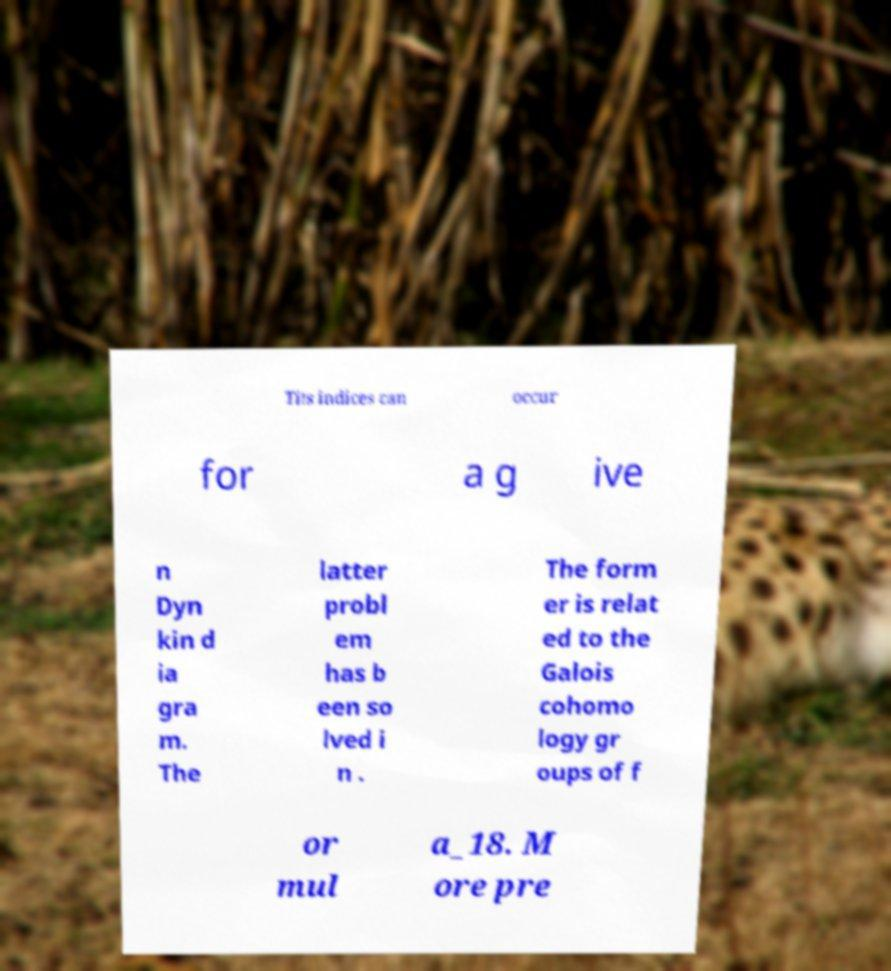What messages or text are displayed in this image? I need them in a readable, typed format. Tits indices can occur for a g ive n Dyn kin d ia gra m. The latter probl em has b een so lved i n . The form er is relat ed to the Galois cohomo logy gr oups of f or mul a_18. M ore pre 